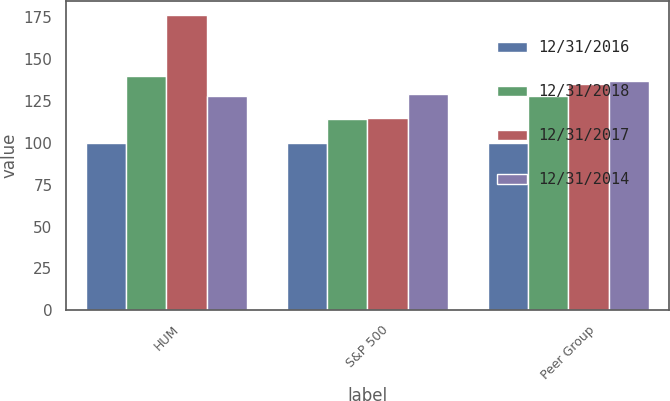Convert chart to OTSL. <chart><loc_0><loc_0><loc_500><loc_500><stacked_bar_chart><ecel><fcel>HUM<fcel>S&P 500<fcel>Peer Group<nl><fcel>12/31/2016<fcel>100<fcel>100<fcel>100<nl><fcel>12/31/2018<fcel>140<fcel>114<fcel>128<nl><fcel>12/31/2017<fcel>176<fcel>115<fcel>135<nl><fcel>12/31/2014<fcel>128<fcel>129<fcel>137<nl></chart> 